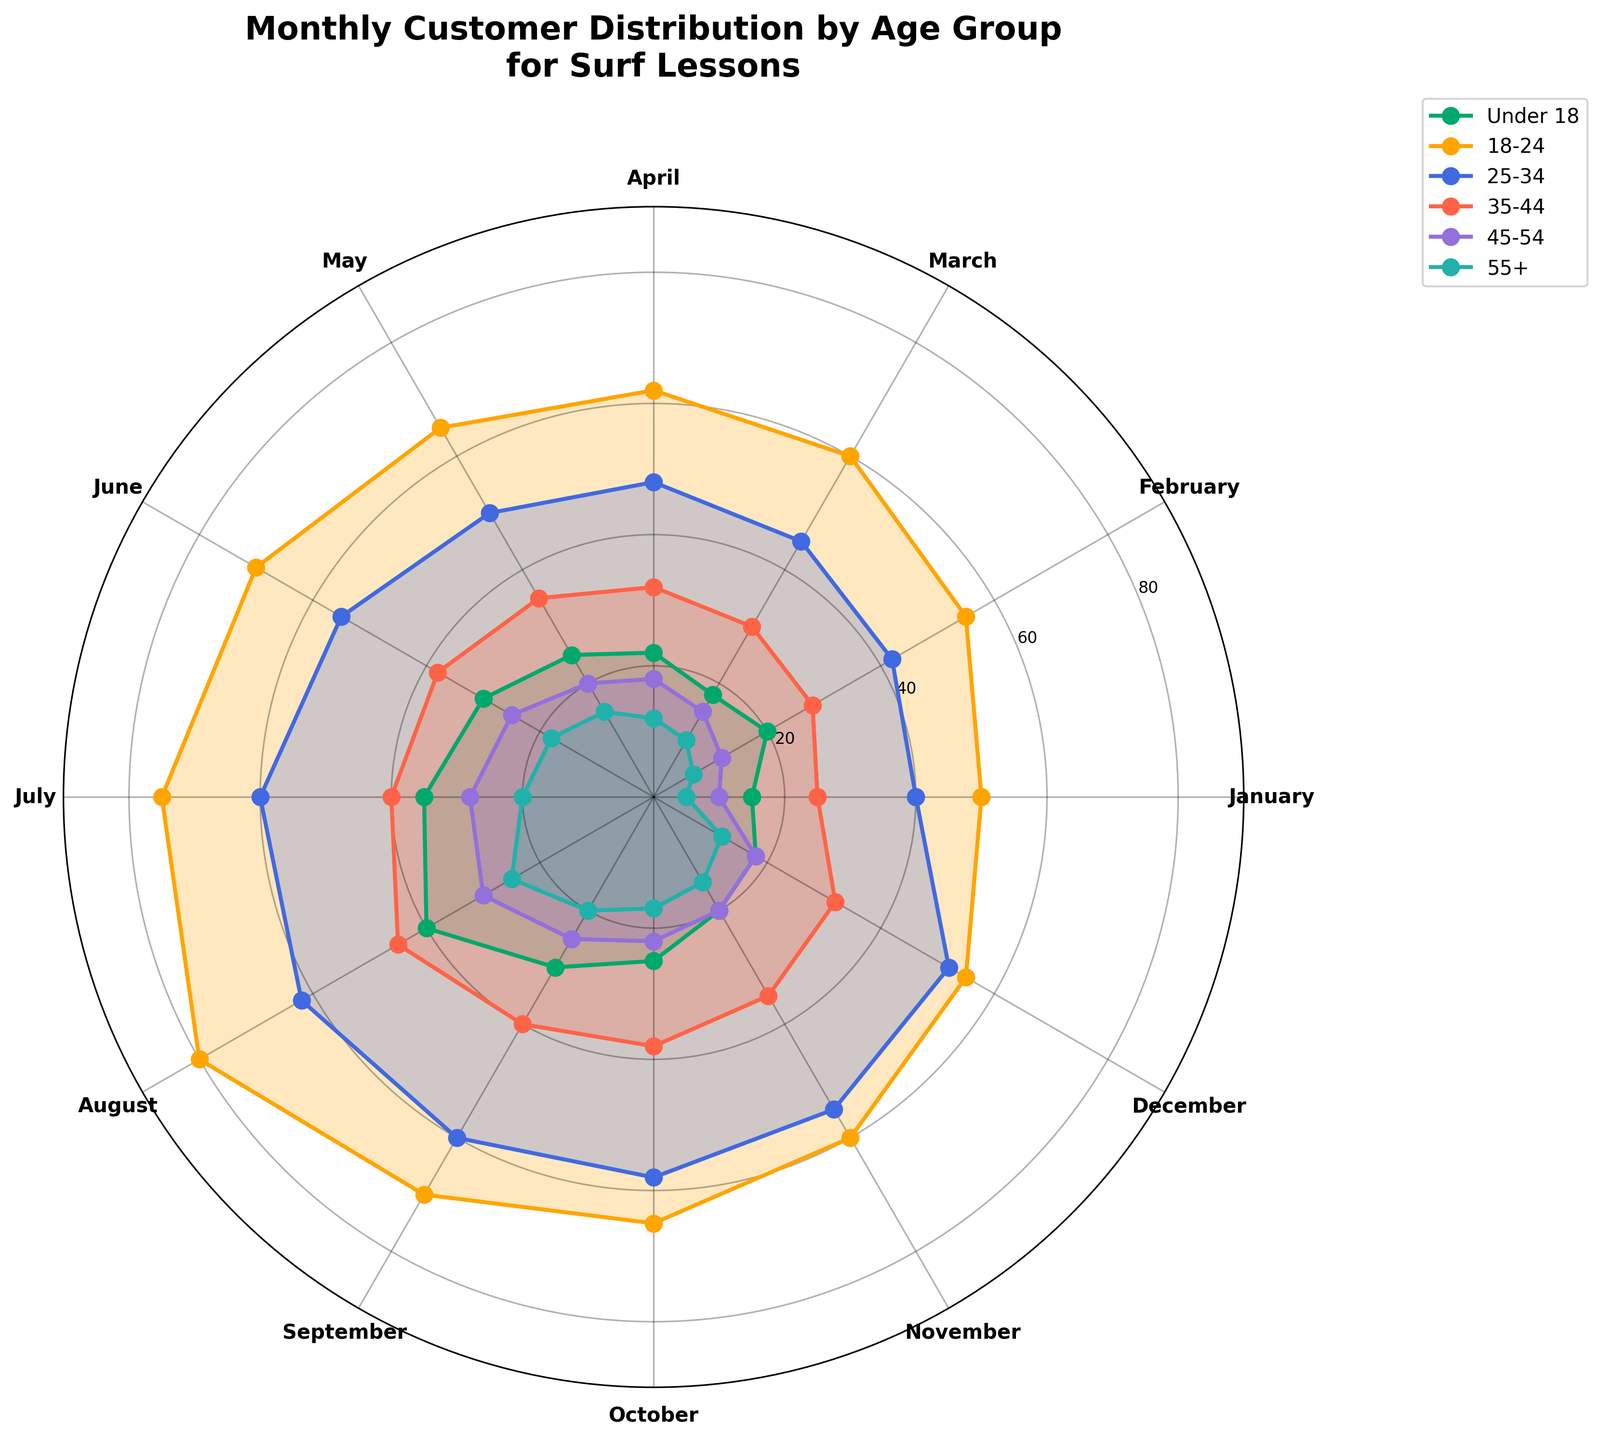Which age group has the highest number of customers in July? Look for the July data point for each age group; the 18-24 age group has the highest number of customers at 75 in that month.
Answer: 18-24 What is the range of customer numbers for the age group 35-44? Observe the minimum and maximum number of customers for this age group across all months. The range is from 25 (January) to 45 (August).
Answer: 20 Which month shows the lowest number of customers in the age group 55+? Check and compare the number of customers for each month in the 55+ age group; January shows the lowest number with 5 customers.
Answer: January Compare the growth pattern between the age groups 25-34 and 45-54 from January to December. Both age groups experience a general increase in customers from January to July, but the 25-34 group sees a gradual increase throughout, whereas the 45-54 group has sharper increment steps. From July to December, both age groups then follow a similar decreasing trend, although the 25-34 age group maintains higher overall numbers.
Answer: Both increase, then decrease, 25-34 is higher How many customers in total visited in March for all age groups? Sum the customer numbers for all age groups in March: 18 (Under 18) + 60 (18-24) + 45 (25-34) + 30 (35-44) + 15 (45-54) + 10 (55+). The total is 178.
Answer: 178 Which months have the highest and lowest variation in customer numbers among age groups? The highest variation is in July, with customer numbers ranging from 75 (18-24) to 20 (55+). The lowest variation is in January, with numbers from 15 (Under 18) to 50 (18-24).
Answer: July highest, January lowest Which age groups have shown a consistent month-on-month increase in customers from January to July? Compare the customer numbers month-by-month for each age group and notice that all age groups have an increasing trend from January to July, with the most consistent being the 18-24 age group.
Answer: All, especially 18-24 What is the total number of customers aged 18-24 across all months? Sum the numbers for 18-24 across all months: 50 + 55 + 60 + 62 + 65 + 70 + 75 + 80 + 70 + 65 + 60 + 55 = 767.
Answer: 767 How does the customer distribution compare between the age groups Under 18 and 55+ in November? In November, the Under 18 age group has 20 customers and the 55+ age group has 15 customers. The Under 18 group has 5 more customers than the 55+ group.
Answer: Under 18 has more Identify any age groups that show a peak in customer numbers in August. Observe the August data for each age group; both Under 18 (40 customers) and 18-24 (80 customers) show peak values in August.
Answer: Under 18, 18-24 